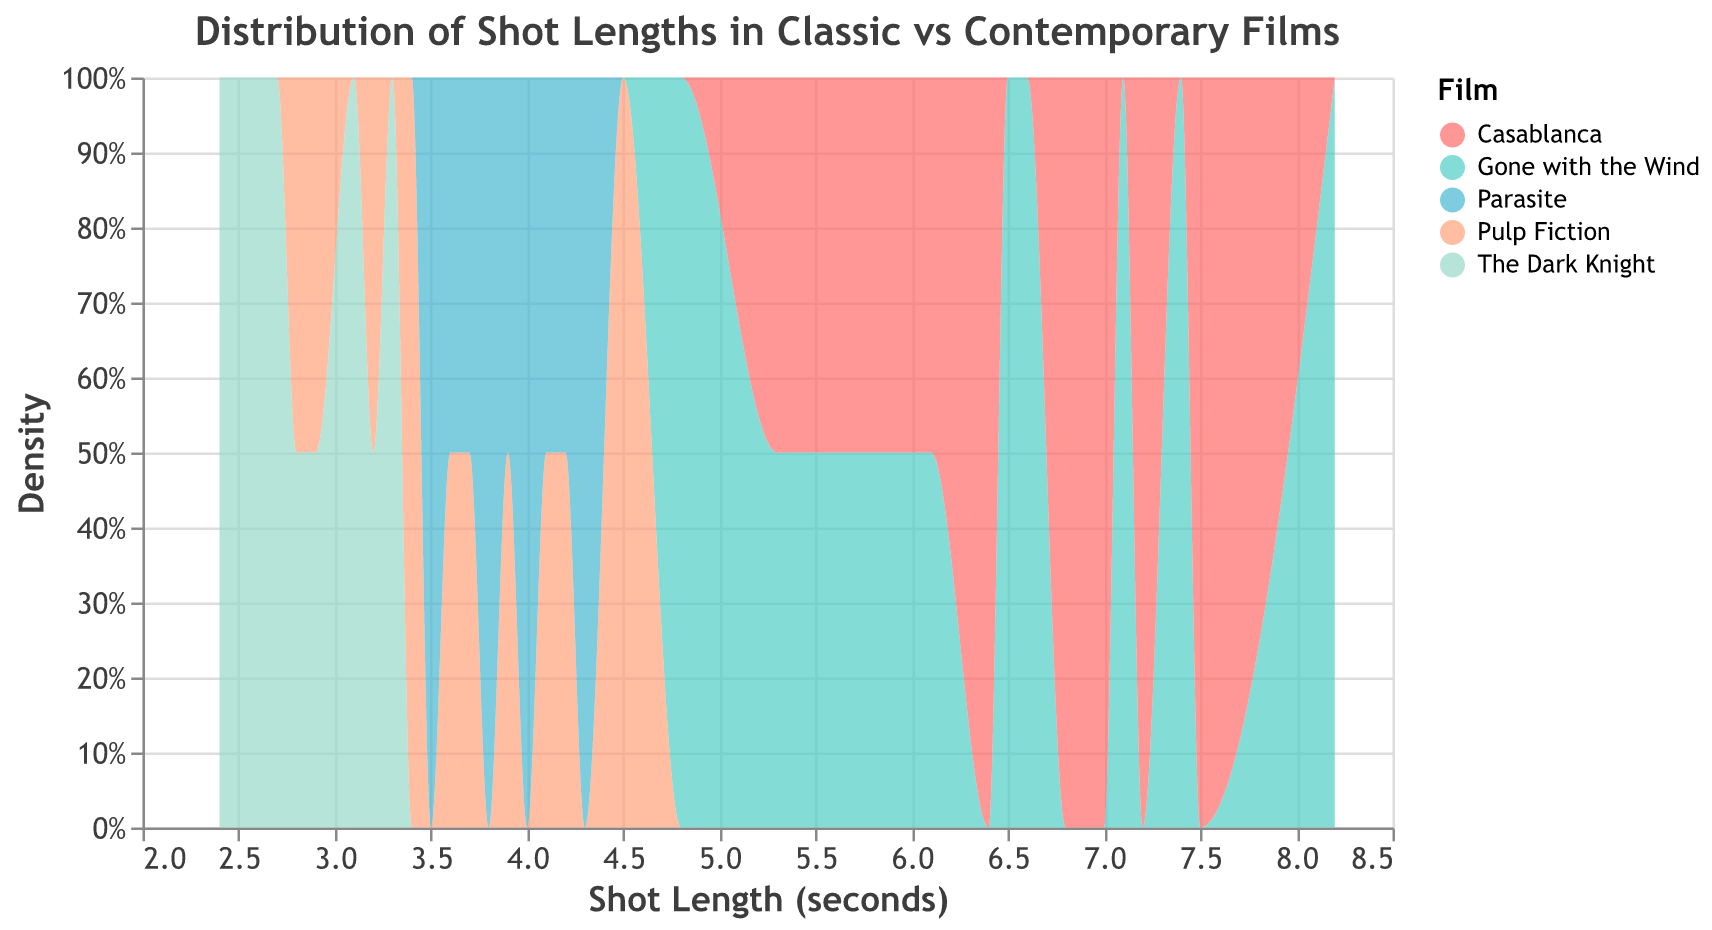What is the title of the figure? The title of the figure is located at the top and usually describes what the plot is showing. In this case, it is titled "Distribution of Shot Lengths in Classic vs Contemporary Films."
Answer: Distribution of Shot Lengths in Classic vs Contemporary Films How many films are represented in the figure? The legend on the right side of the plot provides the names of the films represented in the figure. There are five films listed in the legend.
Answer: Five Which film has the most common shot length around 7 seconds? Observing the density curves, the film with a density peak around 7 seconds can be identified. Casablanca shows a noticeable peak around this shot length.
Answer: Casablanca What is the range of shot lengths represented in "The Dark Knight"? To find this, look at the spread of "The Dark Knight" density curve along the x-axis. The curve starts around 2.4 seconds and ends around 3.3 seconds.
Answer: 2.4 to 3.3 seconds Which film has the shortest average shot length? By comparing the peaks of the density curves, the film with the left-most peak along the x-axis has the shortest average shot length. "The Dark Knight" has its peak at a lower shot length compared to other films.
Answer: The Dark Knight How do the shot lengths of "Gone with the Wind" compare with those of "Pulp Fiction"? Compare the density curves of both films. "Gone with the Wind" has a more spread out distribution with longer shot lengths, while "Pulp Fiction" has shorter and more concentrated shot lengths.
Answer: "Gone with the Wind" has longer shot lengths compared to "Pulp Fiction" For which film is the shot length most consistent? Consistency can be visually determined by the narrowness of the density curve. "The Dark Knight" has a very narrow curve, indicating more consistent shot lengths.
Answer: The Dark Knight What is the general trend in shot lengths from classic to contemporary films? By observing the density plots from older to newer films, there is a noticeable trend where older films ("Gone with the Wind", "Casablanca") have longer shot lengths, and newer films ("Pulp Fiction", "The Dark Knight", "Parasite") have shorter shot lengths.
Answer: Shot lengths have become shorter over time How does the variability in shot lengths for "Parasite" compare to "Pulp Fiction"? Variability can be assessed by the spread of the density curves. Both films have concentrated shot lengths, but "Parasite" shows a slightly narrower curve compared to "Pulp Fiction".
Answer: "Parasite" has slightly less variability What is the highest density value, and for which film does it occur? The highest density value is the peak of any curve on the y-axis. "The Dark Knight" has a very high peak, indicating its most common shot length is very consistent.
Answer: The Dark Knight 